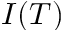Convert formula to latex. <formula><loc_0><loc_0><loc_500><loc_500>I ( T )</formula> 